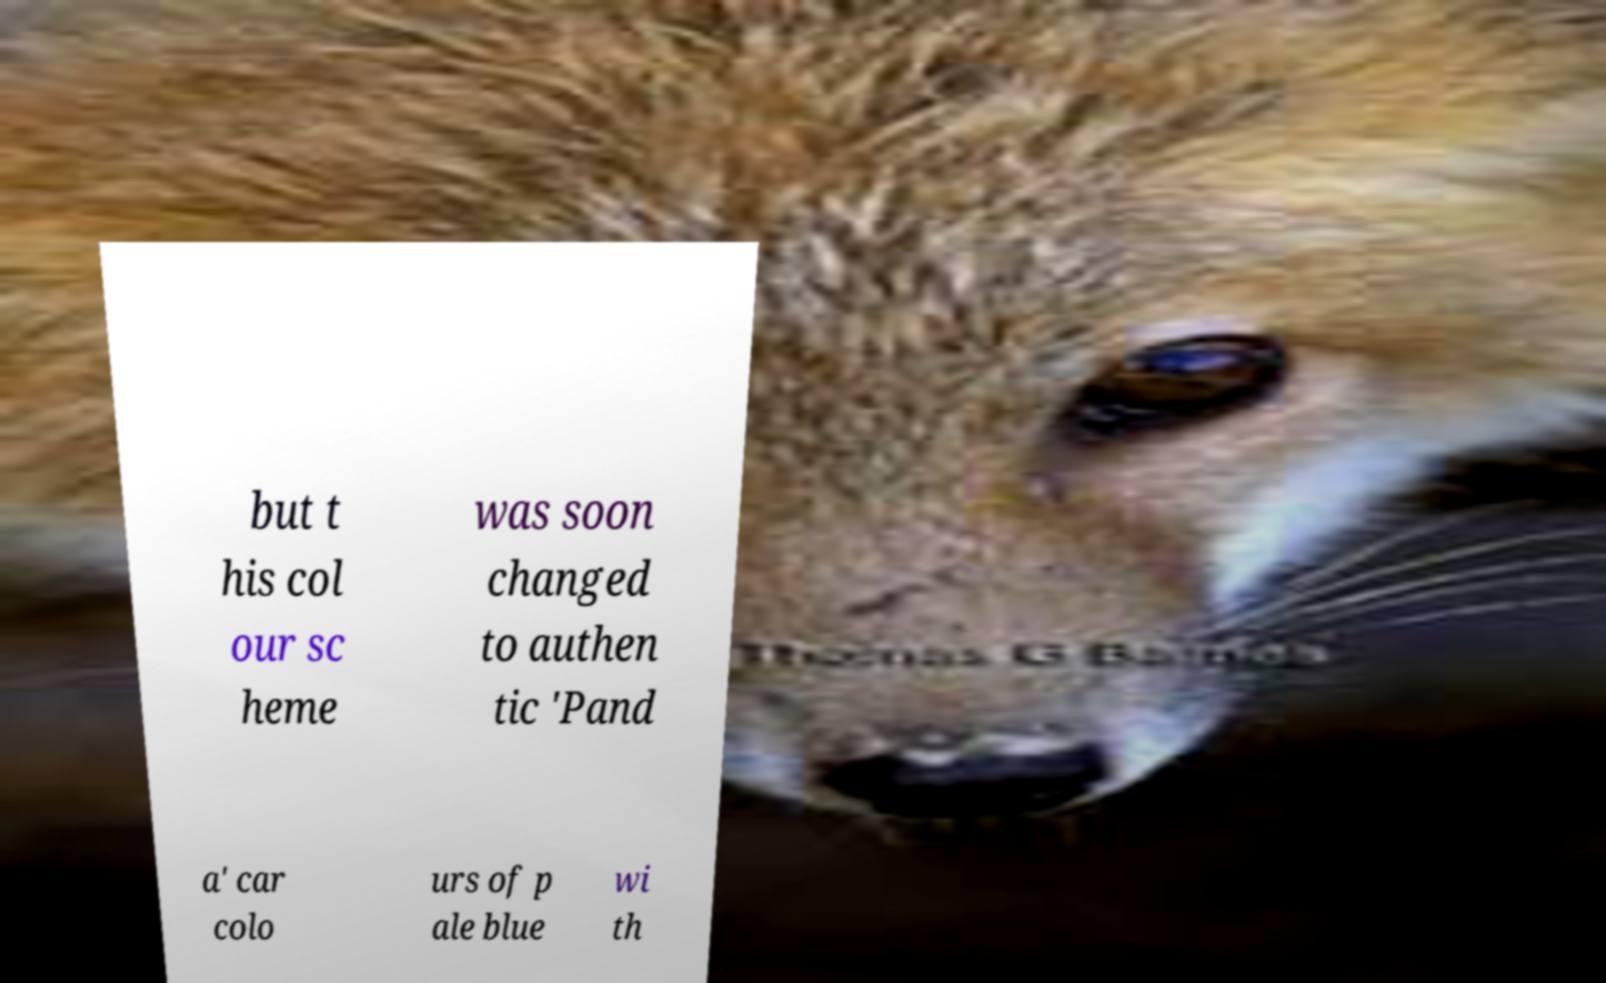Could you extract and type out the text from this image? but t his col our sc heme was soon changed to authen tic 'Pand a' car colo urs of p ale blue wi th 